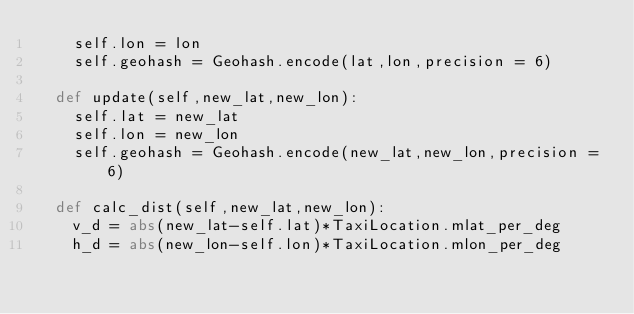<code> <loc_0><loc_0><loc_500><loc_500><_Python_>		self.lon = lon
		self.geohash = Geohash.encode(lat,lon,precision = 6)

	def update(self,new_lat,new_lon):
		self.lat = new_lat
		self.lon = new_lon
		self.geohash = Geohash.encode(new_lat,new_lon,precision = 6)

	def calc_dist(self,new_lat,new_lon):
		v_d = abs(new_lat-self.lat)*TaxiLocation.mlat_per_deg
		h_d = abs(new_lon-self.lon)*TaxiLocation.mlon_per_deg</code> 